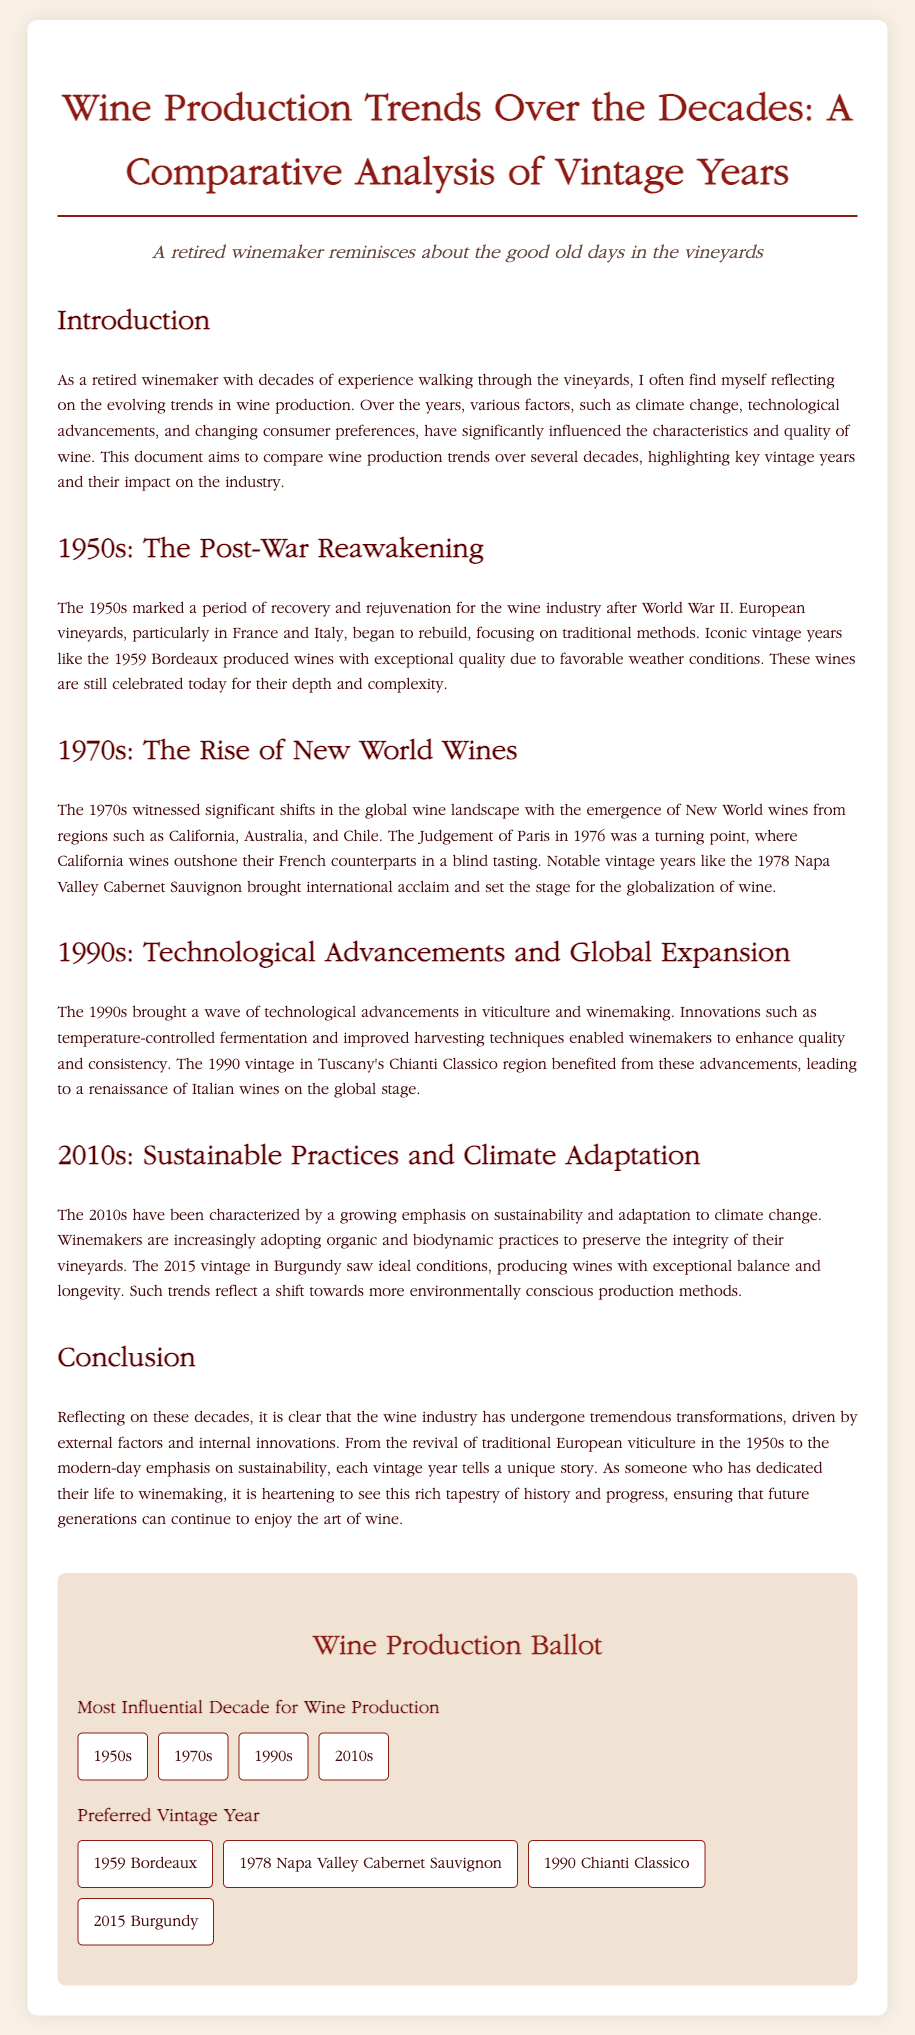What marked the 1950s for the wine industry? The 1950s marked a period of recovery and rejuvenation for the wine industry after World War II.
Answer: Recovery Which vintage year is noted for exceptional quality in the 1950s? The document mentions the iconic vintage year of 1959 Bordeaux for its exceptional quality.
Answer: 1959 Bordeaux What significant event occurred in 1976 related to wine? The Judgement of Paris in 1976 was a turning point where California wines outshone their French counterparts.
Answer: Judgement of Paris What advancements were prominent in the 1990s winemaking? The 1990s brought technological advancements such as temperature-controlled fermentation and improved harvesting techniques.
Answer: Technological advancements Which vintage year in Burgundy produced wines with exceptional balance? The 2015 vintage in Burgundy is noted for producing wines with exceptional balance and longevity.
Answer: 2015 What type of practices have gained emphasis in the 2010s? The document states that there has been a growing emphasis on sustainability and adaptation to climate change.
Answer: Sustainability What vintage year is preferred for the 1990s option in the ballot? The ballot includes 1990 Chianti Classico as the preferred vintage year option.
Answer: 1990 Chianti Classico Which decade is considered most influential for wine production according to the ballot? The ballot provides options including the 1950s, 1970s, 1990s, and 2010s for the most influential decade.
Answer: 1950s, 1970s, 1990s, 2010s What is the title of the document? The document is titled "Wine Production Trends Over the Decades: A Comparative Analysis".
Answer: Wine Production Trends Over the Decades: A Comparative Analysis How many ballot options are presented in the document? There are two ballot options presented: Most Influential Decade for Wine Production and Preferred Vintage Year.
Answer: Two 